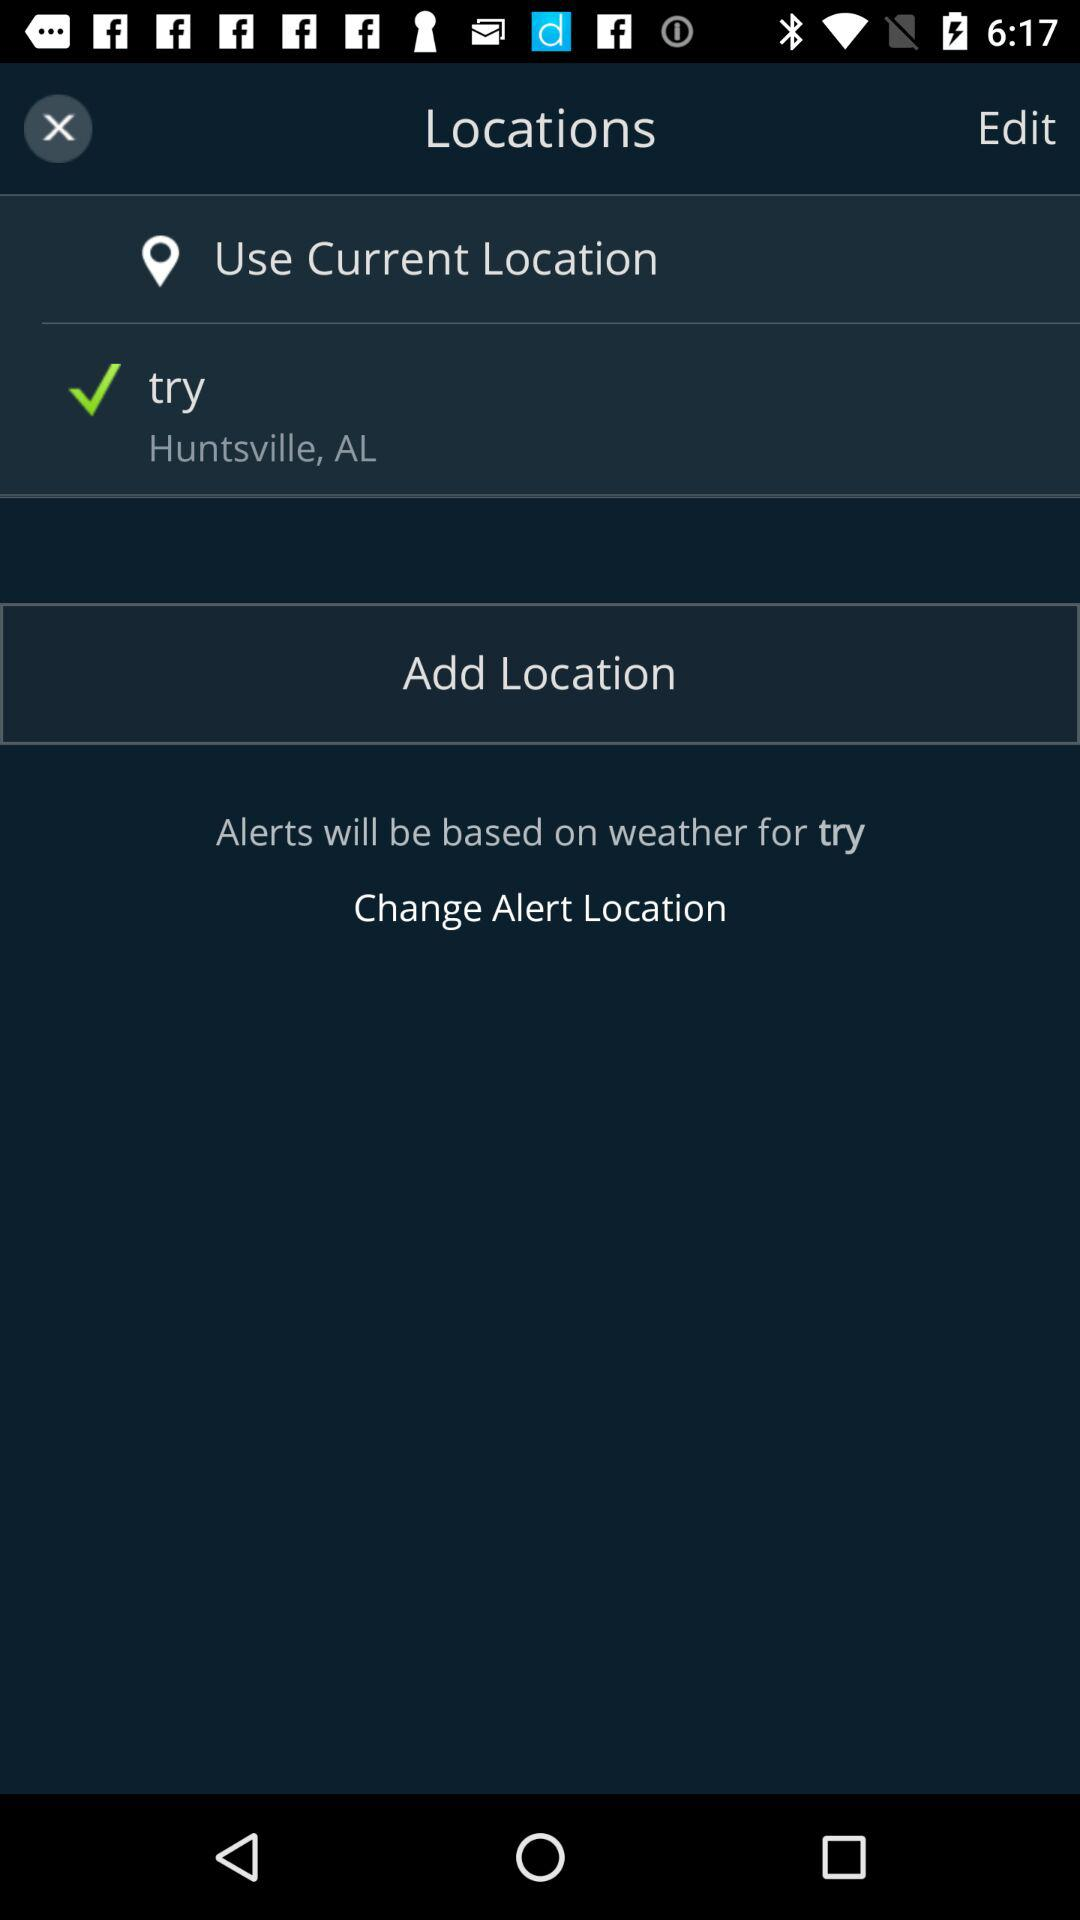For whom will the weather alerts be based? The weather alerts will be based for "try". 